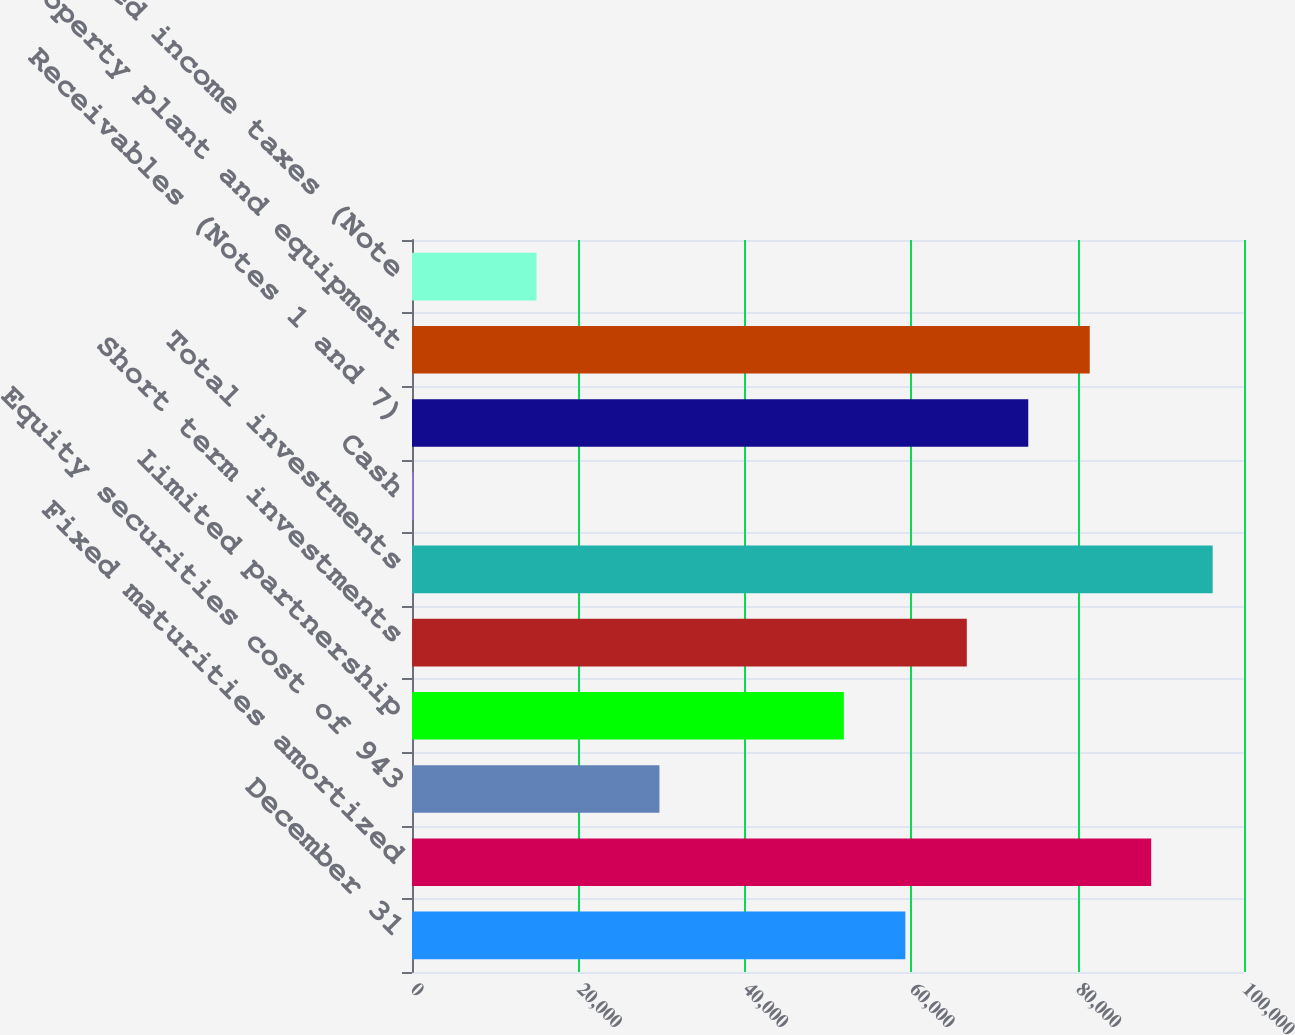<chart> <loc_0><loc_0><loc_500><loc_500><bar_chart><fcel>December 31<fcel>Fixed maturities amortized<fcel>Equity securities cost of 943<fcel>Limited partnership<fcel>Short term investments<fcel>Total investments<fcel>Cash<fcel>Receivables (Notes 1 and 7)<fcel>Property plant and equipment<fcel>Deferred income taxes (Note<nl><fcel>59294<fcel>88846<fcel>29742<fcel>51906<fcel>66682<fcel>96234<fcel>190<fcel>74070<fcel>81458<fcel>14966<nl></chart> 